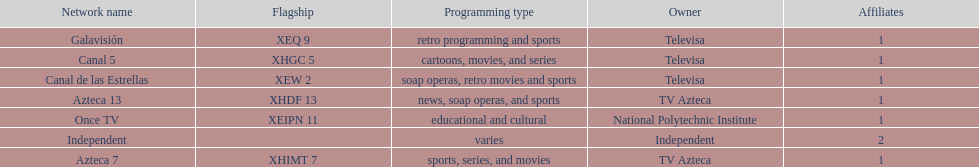What station shows cartoons? Canal 5. What station shows soap operas? Canal de las Estrellas. What station shows sports? Azteca 7. 